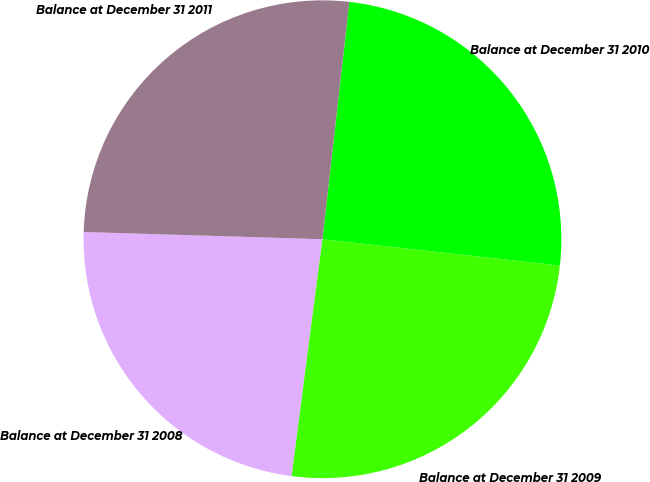Convert chart to OTSL. <chart><loc_0><loc_0><loc_500><loc_500><pie_chart><fcel>Balance at December 31 2008<fcel>Balance at December 31 2009<fcel>Balance at December 31 2010<fcel>Balance at December 31 2011<nl><fcel>23.42%<fcel>25.3%<fcel>24.96%<fcel>26.31%<nl></chart> 